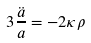Convert formula to latex. <formula><loc_0><loc_0><loc_500><loc_500>3 \frac { \ddot { a } } { a } = - 2 \kappa \rho</formula> 